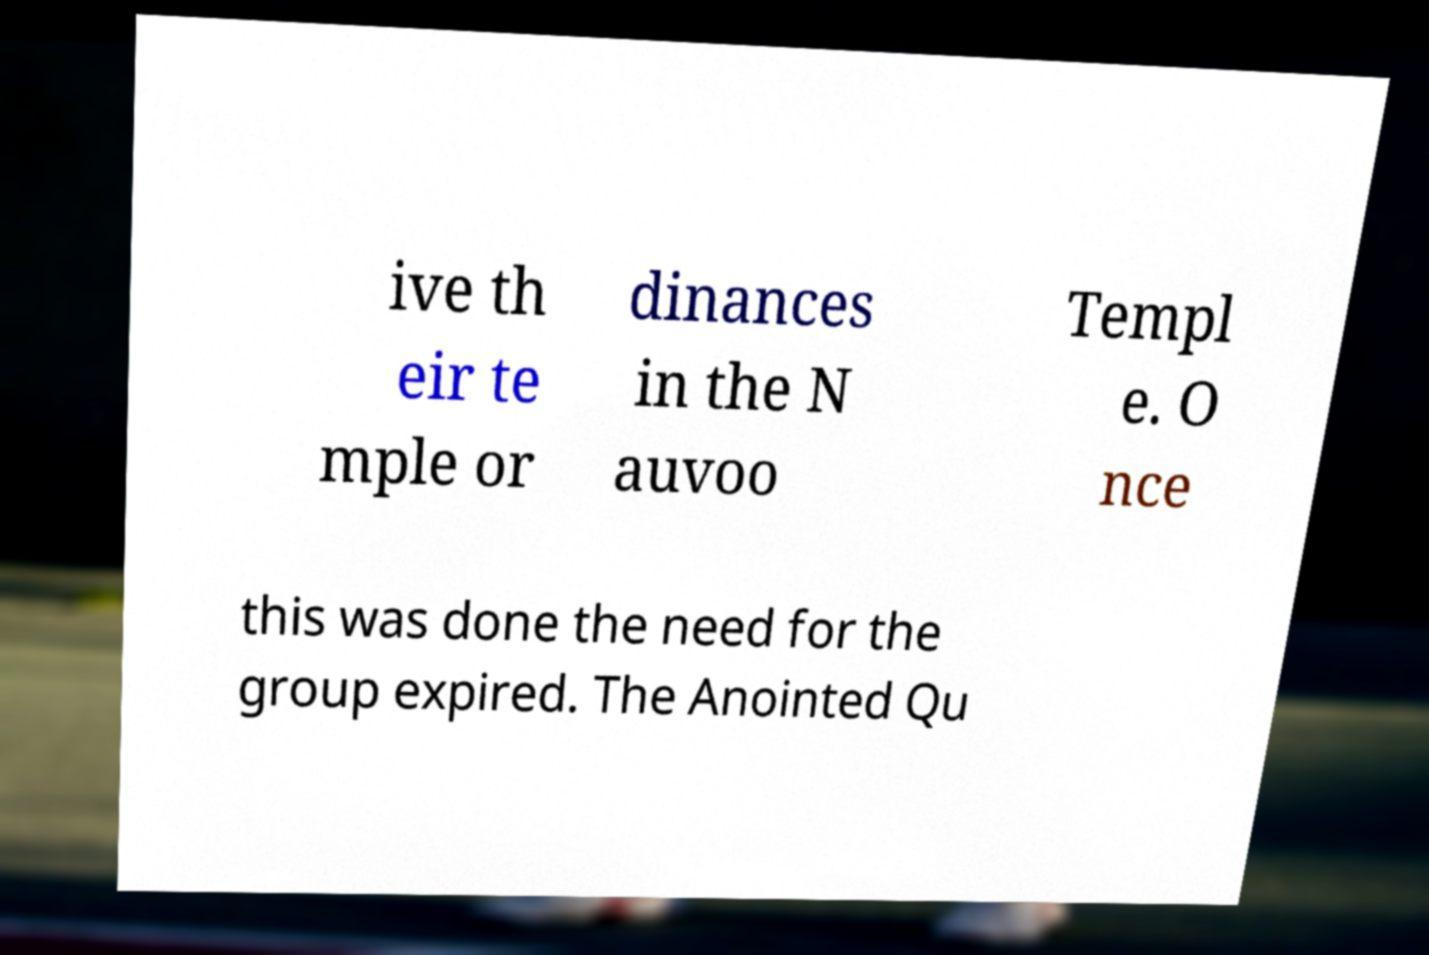Please identify and transcribe the text found in this image. ive th eir te mple or dinances in the N auvoo Templ e. O nce this was done the need for the group expired. The Anointed Qu 